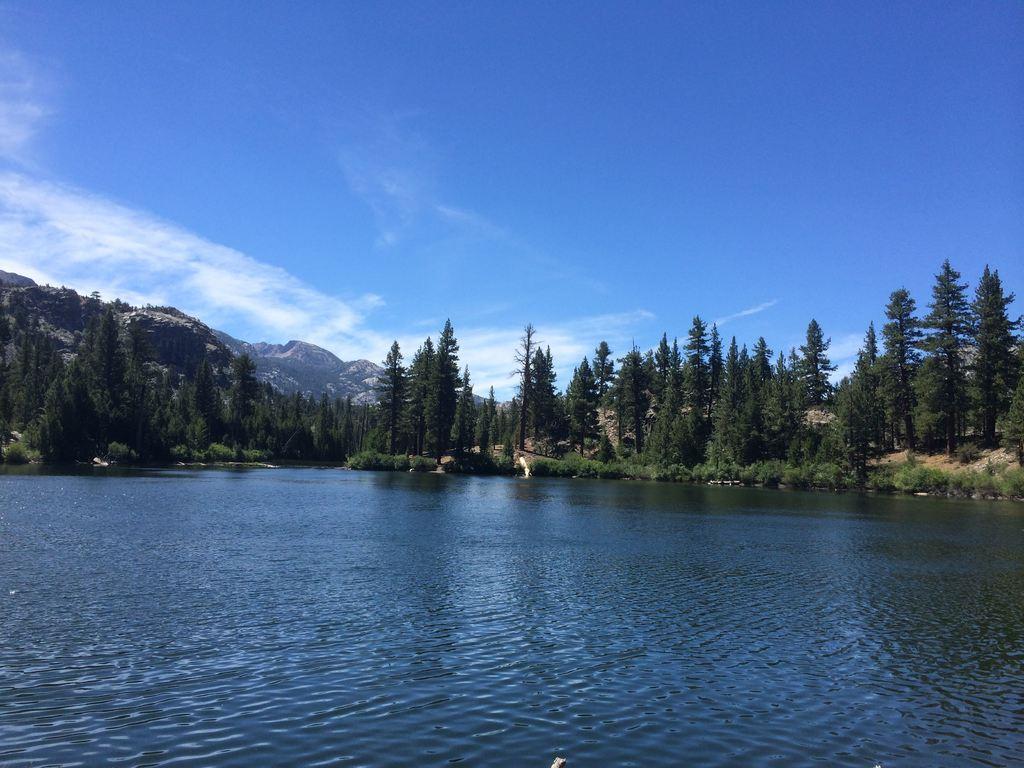Could you give a brief overview of what you see in this image? In this image there is water, grass, plants, trees,hills,sky. 